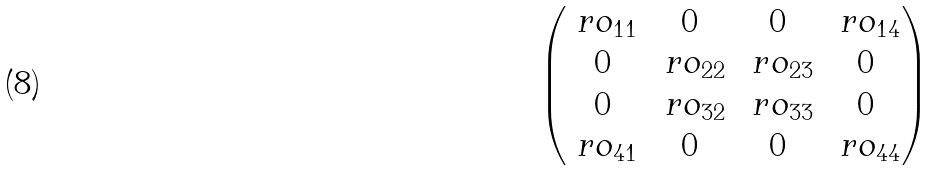<formula> <loc_0><loc_0><loc_500><loc_500>\begin{pmatrix} \ r o _ { 1 1 } & 0 & 0 & \ r o _ { 1 4 } \\ 0 & \ r o _ { 2 2 } & \ r o _ { 2 3 } & 0 \\ 0 & \ r o _ { 3 2 } & \ r o _ { 3 3 } & 0 \\ \ r o _ { 4 1 } & 0 & 0 & \ r o _ { 4 4 } \end{pmatrix}</formula> 